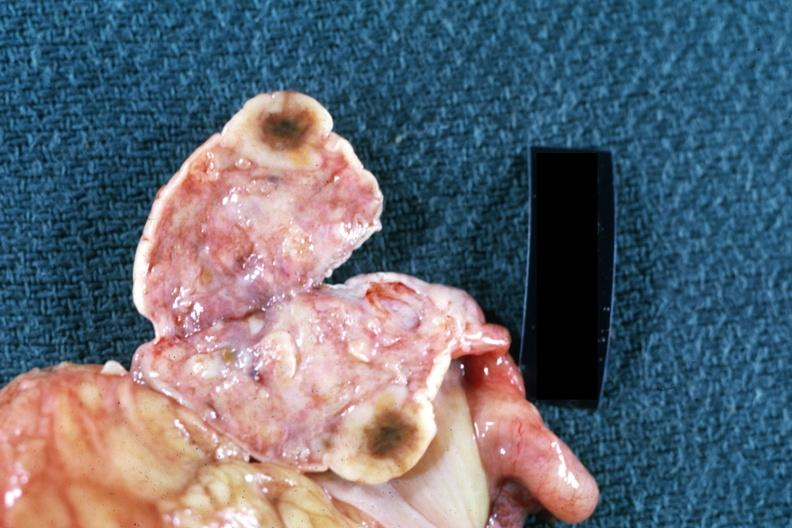s simian crease present?
Answer the question using a single word or phrase. No 